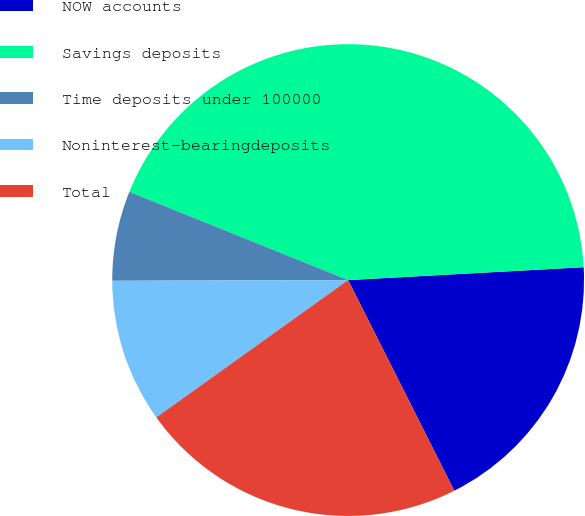Convert chart to OTSL. <chart><loc_0><loc_0><loc_500><loc_500><pie_chart><fcel>NOW accounts<fcel>Savings deposits<fcel>Time deposits under 100000<fcel>Noninterest-bearingdeposits<fcel>Total<nl><fcel>18.44%<fcel>43.03%<fcel>6.15%<fcel>9.84%<fcel>22.54%<nl></chart> 